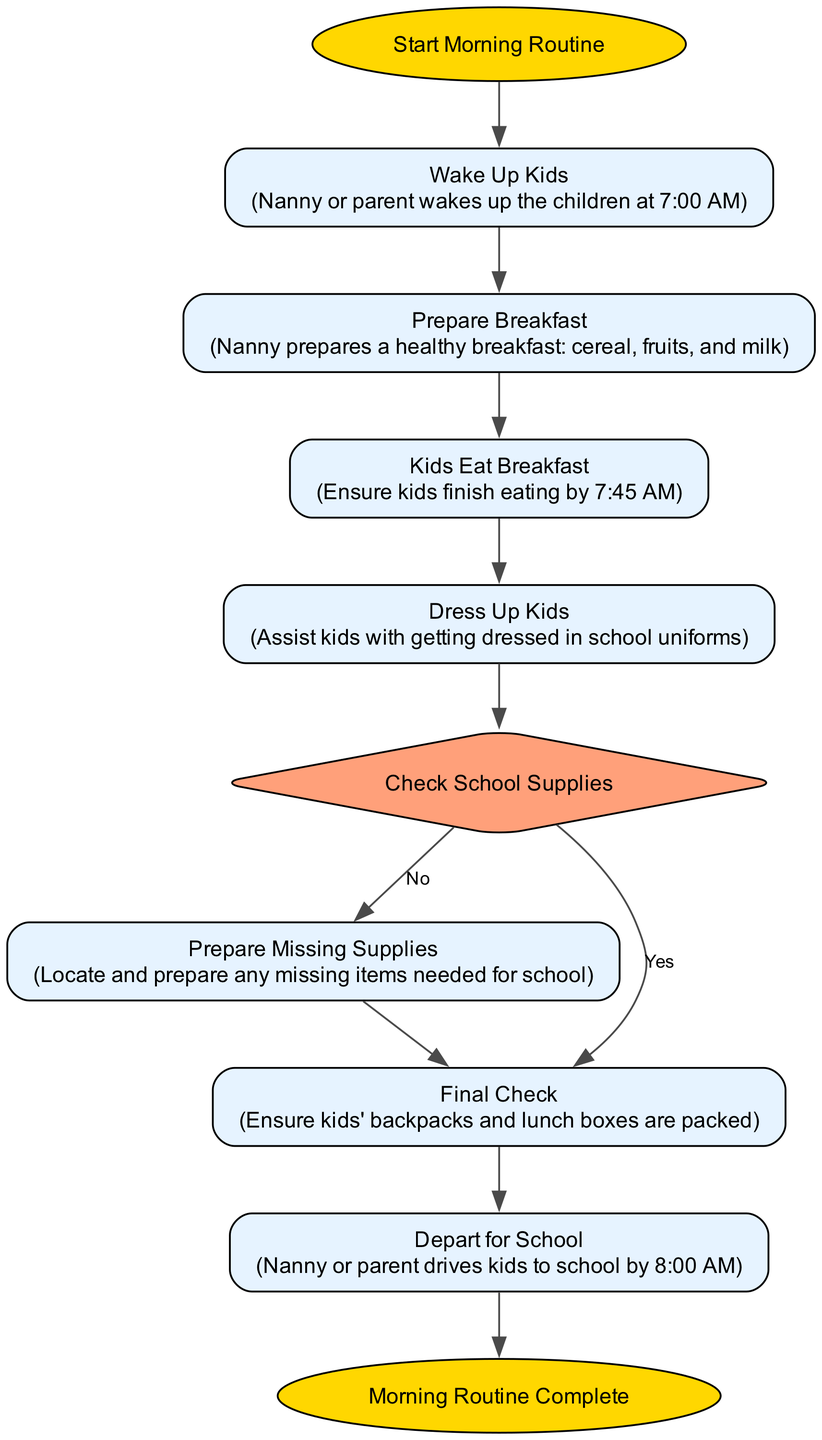What is the first step in the morning routine? The first step in the diagram is labeled "Start Morning Routine," which leads directly to the next step, "Wake Up Kids."
Answer: Wake Up Kids What time do the kids wake up? The diagram specifies that the kids are woken up at 7:00 AM by the nanny or parent, as described in the "Wake Up Kids" process.
Answer: 7:00 AM What must be prepared for breakfast? The diagram indicates that the nanny prepares a healthy breakfast, which includes cereal, fruits, and milk, as shown in the "Prepare Breakfast" process.
Answer: Cereal, fruits, and milk What is the final step before leaving for school? The last step before departing for school is the "Final Check," which ensures that the kids' backpacks and lunch boxes are packed before moving to "Depart for School."
Answer: Final Check Is there a step for checking school supplies? Yes, there is a decision node labeled "Check School Supplies," where it is assessed whether the kids have all needed supplies and homework.
Answer: Yes What happens if the kids don't have all their supplies? If the kids don't have all their supplies, the flow directs to "Prepare Missing Supplies," which involves locating and preparing any missing items needed for school.
Answer: Prepare Missing Supplies How many processes are there in this morning routine? The diagram includes a total of five processes: "Prepare Breakfast," "Kids Eat Breakfast," "Dress Up Kids," "Prepare Missing Supplies" (if needed), and "Final Check."
Answer: Five processes What is the last task performed in the routine? The diagram concludes with the task labeled "Depart for School," which is the final action before the morning routine is marked as complete.
Answer: Depart for School What time do the kids need to leave home? According to the diagram, the kids need to depart for school by 8:00 AM, as specified in the "Depart for School" process.
Answer: 8:00 AM 